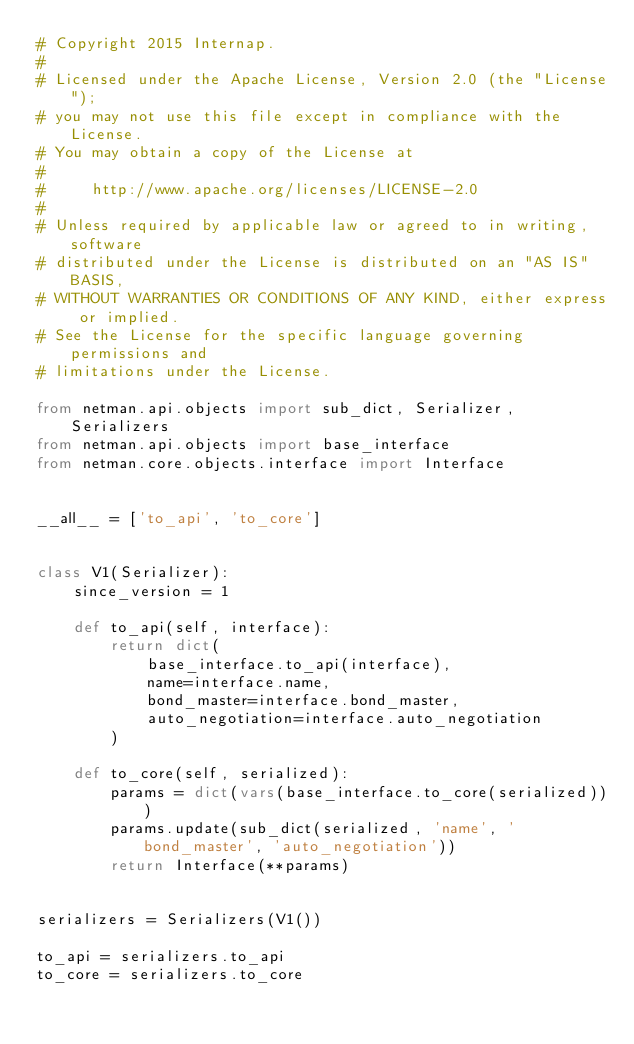<code> <loc_0><loc_0><loc_500><loc_500><_Python_># Copyright 2015 Internap.
#
# Licensed under the Apache License, Version 2.0 (the "License");
# you may not use this file except in compliance with the License.
# You may obtain a copy of the License at
#
#     http://www.apache.org/licenses/LICENSE-2.0
#
# Unless required by applicable law or agreed to in writing, software
# distributed under the License is distributed on an "AS IS" BASIS,
# WITHOUT WARRANTIES OR CONDITIONS OF ANY KIND, either express or implied.
# See the License for the specific language governing permissions and
# limitations under the License.

from netman.api.objects import sub_dict, Serializer, Serializers
from netman.api.objects import base_interface
from netman.core.objects.interface import Interface


__all__ = ['to_api', 'to_core']


class V1(Serializer):
    since_version = 1

    def to_api(self, interface):
        return dict(
            base_interface.to_api(interface),
            name=interface.name,
            bond_master=interface.bond_master,
            auto_negotiation=interface.auto_negotiation
        )

    def to_core(self, serialized):
        params = dict(vars(base_interface.to_core(serialized)))
        params.update(sub_dict(serialized, 'name', 'bond_master', 'auto_negotiation'))
        return Interface(**params)


serializers = Serializers(V1())

to_api = serializers.to_api
to_core = serializers.to_core
</code> 